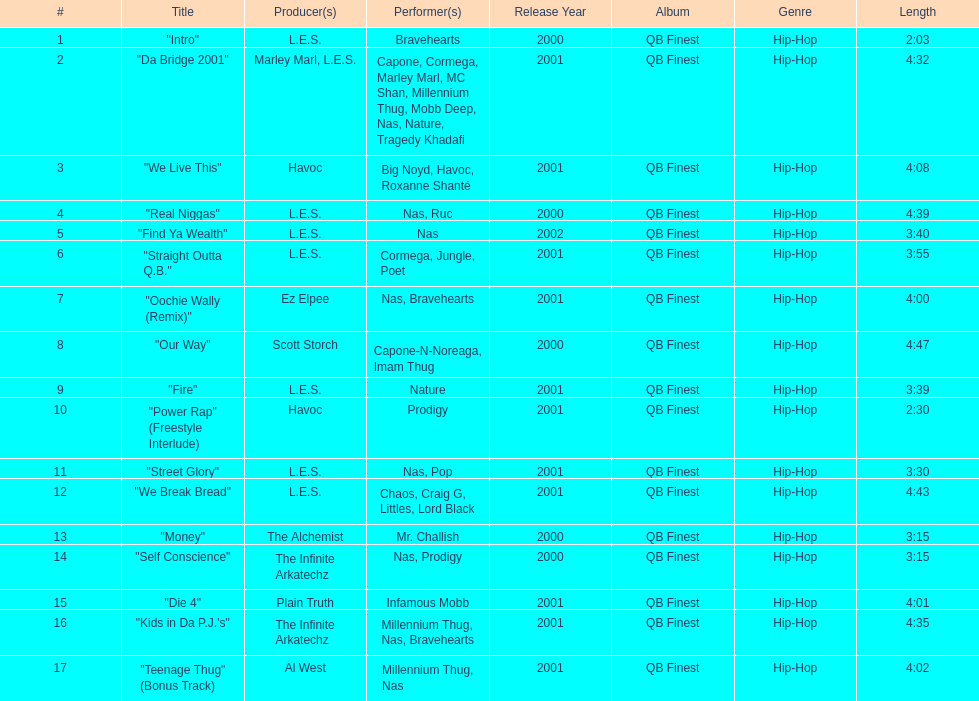Following street glory, which song is mentioned? "We Break Bread". 